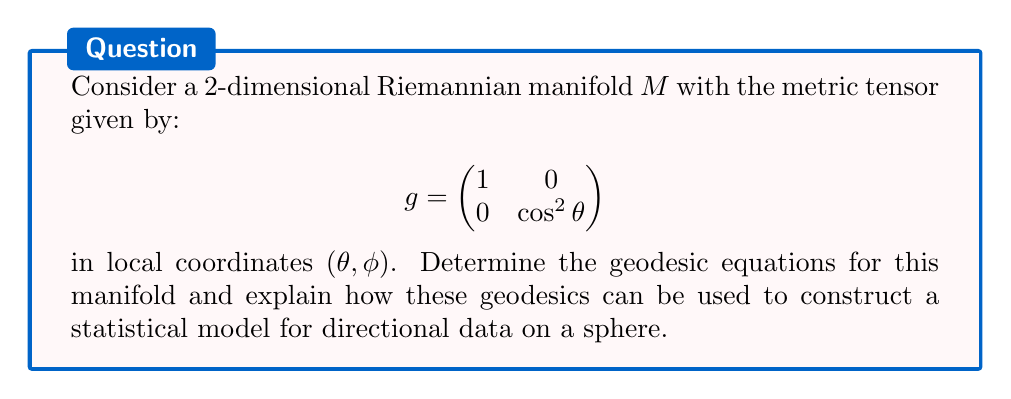Could you help me with this problem? 1) First, we need to calculate the Christoffel symbols for this metric. The non-zero Christoffel symbols are:

   $$\Gamma^2_{12} = \Gamma^2_{21} = \tan \theta$$
   $$\Gamma^1_{22} = -\sin \theta \cos \theta$$

2) The geodesic equations are given by:

   $$\frac{d^2x^i}{dt^2} + \Gamma^i_{jk}\frac{dx^j}{dt}\frac{dx^k}{dt} = 0$$

   where $x^i$ represents the coordinates $(\theta, \phi)$.

3) Substituting the Christoffel symbols, we get:

   $$\frac{d^2\theta}{dt^2} - \sin \theta \cos \theta \left(\frac{d\phi}{dt}\right)^2 = 0$$
   $$\frac{d^2\phi}{dt^2} + 2\tan \theta \frac{d\theta}{dt}\frac{d\phi}{dt} = 0$$

4) These equations describe great circles on a sphere, which are the geodesics for this manifold.

5) In statistical analysis, these geodesics can be used to model directional data on a sphere. For example:

   a) The von Mises-Fisher distribution, a probability distribution on the sphere, has density function:

      $$f(x; \mu, \kappa) = C(\kappa) \exp(\kappa \mu^T x)$$

      where $\mu$ is the mean direction and $\kappa$ is the concentration parameter.

   b) The geodesic distance between two points on the sphere can be used as a measure of dissimilarity in clustering algorithms for directional data.

   c) Regression models for directional data can be developed using the geodesic distance as a loss function, leading to geodesic regression.

6) These statistical models are particularly useful in fields such as geoscience, astronomy, and bioinformatics, where data often naturally occurs on the surface of a sphere.
Answer: Geodesic equations: $\frac{d^2\theta}{dt^2} - \sin \theta \cos \theta \left(\frac{d\phi}{dt}\right)^2 = 0$, $\frac{d^2\phi}{dt^2} + 2\tan \theta \frac{d\theta}{dt}\frac{d\phi}{dt} = 0$. Applications: von Mises-Fisher distribution, clustering, geodesic regression for directional data on a sphere. 